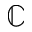<formula> <loc_0><loc_0><loc_500><loc_500>\mathbb { C }</formula> 